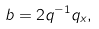<formula> <loc_0><loc_0><loc_500><loc_500>b = 2 q ^ { - 1 } q _ { x } ,</formula> 